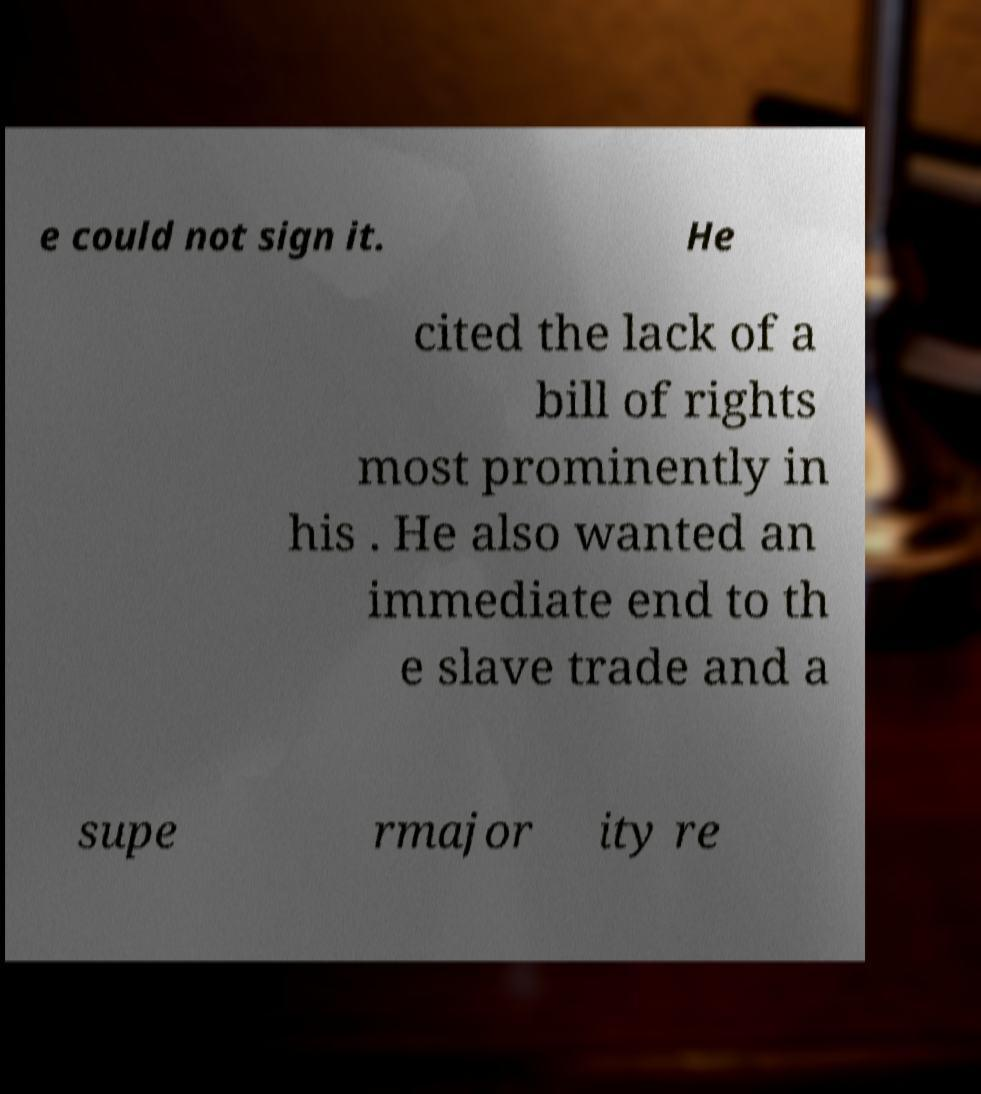There's text embedded in this image that I need extracted. Can you transcribe it verbatim? e could not sign it. He cited the lack of a bill of rights most prominently in his . He also wanted an immediate end to th e slave trade and a supe rmajor ity re 